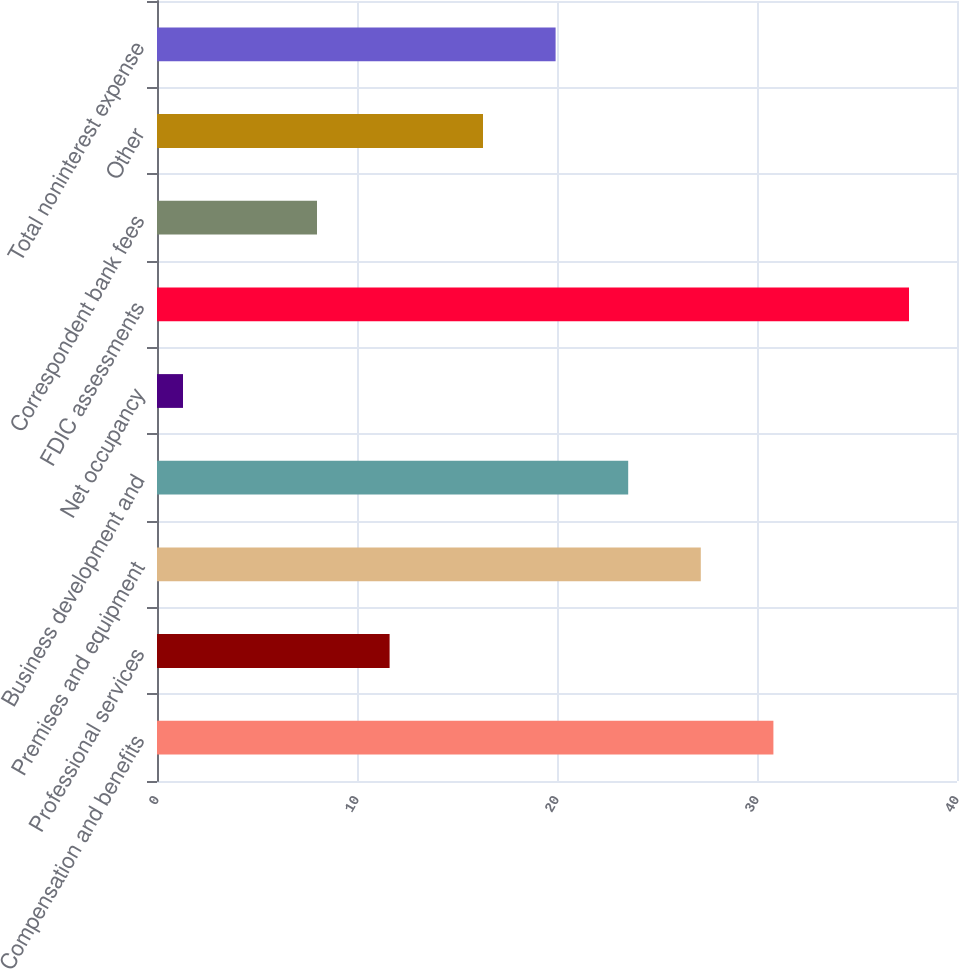Convert chart to OTSL. <chart><loc_0><loc_0><loc_500><loc_500><bar_chart><fcel>Compensation and benefits<fcel>Professional services<fcel>Premises and equipment<fcel>Business development and<fcel>Net occupancy<fcel>FDIC assessments<fcel>Correspondent bank fees<fcel>Other<fcel>Total noninterest expense<nl><fcel>30.82<fcel>11.63<fcel>27.19<fcel>23.56<fcel>1.3<fcel>37.6<fcel>8<fcel>16.3<fcel>19.93<nl></chart> 